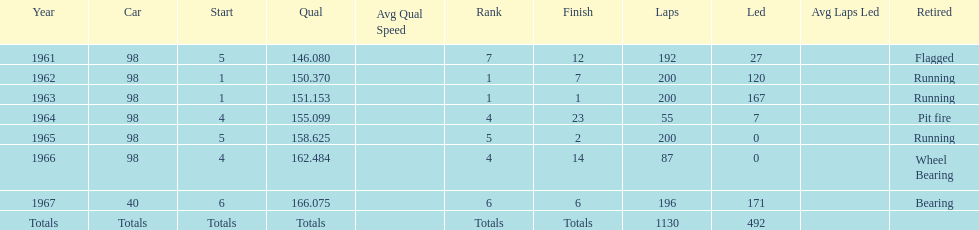What is the most common cause for a retired car? Running. 